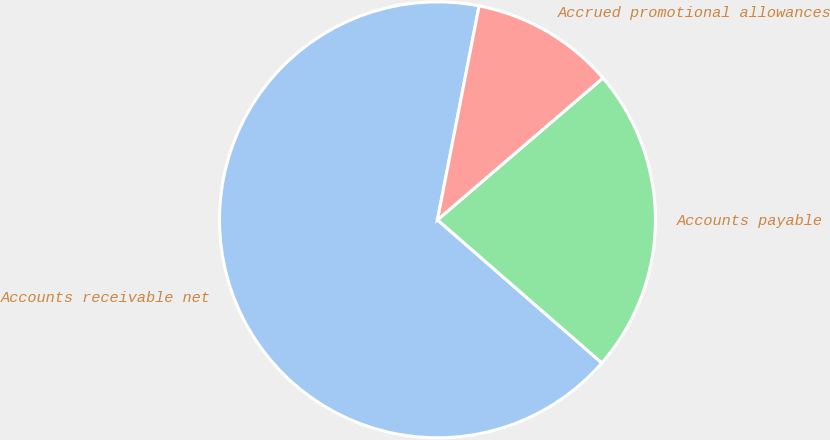Convert chart to OTSL. <chart><loc_0><loc_0><loc_500><loc_500><pie_chart><fcel>Accounts receivable net<fcel>Accounts payable<fcel>Accrued promotional allowances<nl><fcel>66.66%<fcel>22.68%<fcel>10.66%<nl></chart> 